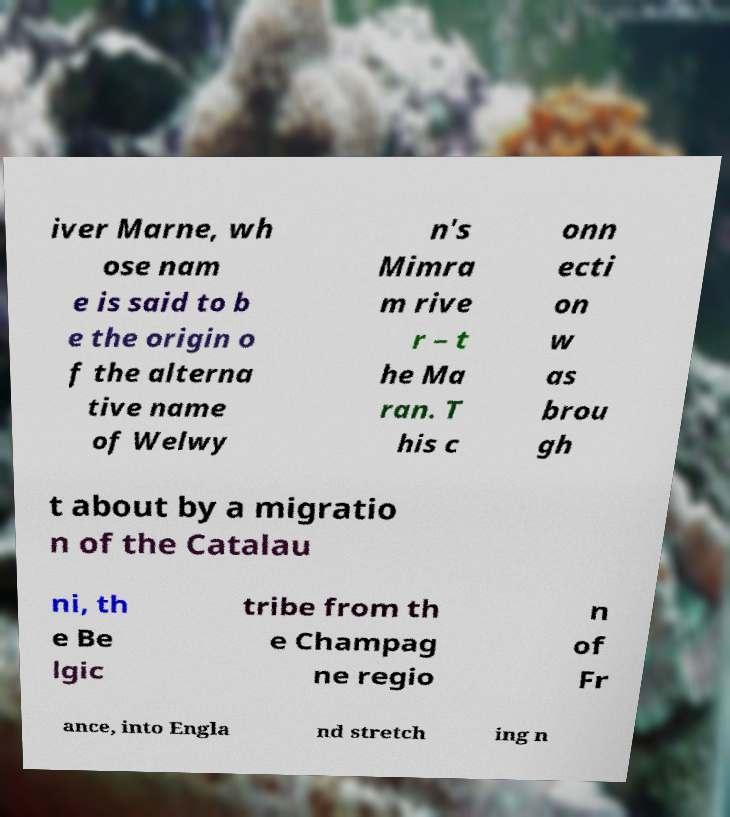Can you accurately transcribe the text from the provided image for me? iver Marne, wh ose nam e is said to b e the origin o f the alterna tive name of Welwy n's Mimra m rive r – t he Ma ran. T his c onn ecti on w as brou gh t about by a migratio n of the Catalau ni, th e Be lgic tribe from th e Champag ne regio n of Fr ance, into Engla nd stretch ing n 